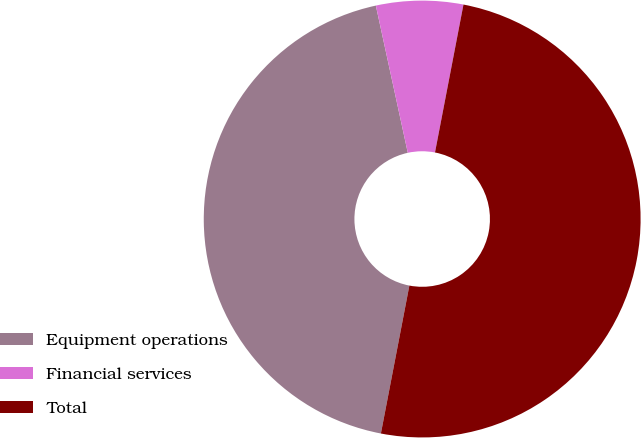<chart> <loc_0><loc_0><loc_500><loc_500><pie_chart><fcel>Equipment operations<fcel>Financial services<fcel>Total<nl><fcel>43.57%<fcel>6.43%<fcel>50.0%<nl></chart> 